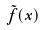Convert formula to latex. <formula><loc_0><loc_0><loc_500><loc_500>\tilde { f } ( x )</formula> 